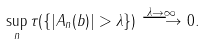Convert formula to latex. <formula><loc_0><loc_0><loc_500><loc_500>\sup _ { n } \tau ( \{ | A _ { n } ( b ) | > \lambda \} ) \stackrel { \lambda \rightarrow \infty } \longrightarrow 0 .</formula> 